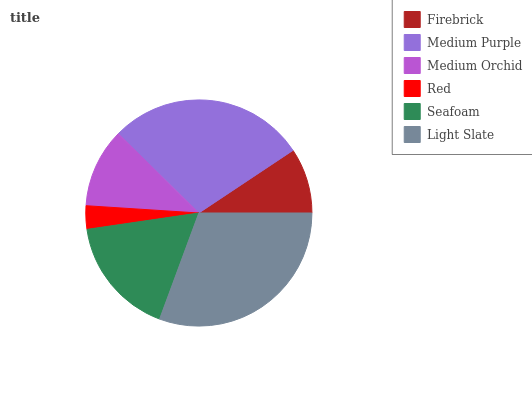Is Red the minimum?
Answer yes or no. Yes. Is Light Slate the maximum?
Answer yes or no. Yes. Is Medium Purple the minimum?
Answer yes or no. No. Is Medium Purple the maximum?
Answer yes or no. No. Is Medium Purple greater than Firebrick?
Answer yes or no. Yes. Is Firebrick less than Medium Purple?
Answer yes or no. Yes. Is Firebrick greater than Medium Purple?
Answer yes or no. No. Is Medium Purple less than Firebrick?
Answer yes or no. No. Is Seafoam the high median?
Answer yes or no. Yes. Is Medium Orchid the low median?
Answer yes or no. Yes. Is Medium Purple the high median?
Answer yes or no. No. Is Red the low median?
Answer yes or no. No. 